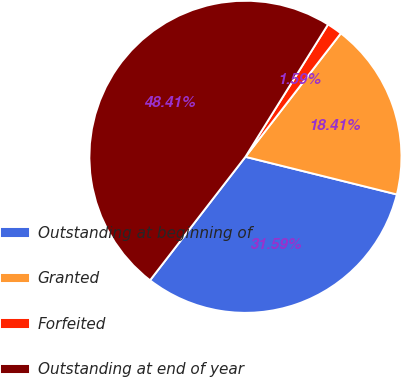<chart> <loc_0><loc_0><loc_500><loc_500><pie_chart><fcel>Outstanding at beginning of<fcel>Granted<fcel>Forfeited<fcel>Outstanding at end of year<nl><fcel>31.59%<fcel>18.41%<fcel>1.59%<fcel>48.41%<nl></chart> 